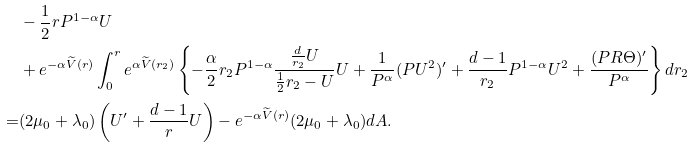<formula> <loc_0><loc_0><loc_500><loc_500>& - \frac { 1 } { 2 } r P ^ { 1 - \alpha } U \\ & + e ^ { - \alpha \widetilde { V } ( r ) } \int _ { 0 } ^ { r } e ^ { \alpha \widetilde { V } ( r _ { 2 } ) } \left \{ - \frac { \alpha } { 2 } r _ { 2 } P ^ { 1 - \alpha } \frac { \frac { d } { r _ { 2 } } U } { \frac { 1 } { 2 } r _ { 2 } - U } U + \frac { 1 } { P ^ { \alpha } } ( P U ^ { 2 } ) ^ { \prime } + \frac { d - 1 } { r _ { 2 } } P ^ { 1 - \alpha } U ^ { 2 } + \frac { ( P R \Theta ) ^ { \prime } } { P ^ { \alpha } } \right \} d r _ { 2 } \\ = & ( 2 \mu _ { 0 } + \lambda _ { 0 } ) \left ( U ^ { \prime } + \frac { d - 1 } { r } U \right ) - e ^ { - \alpha \widetilde { V } ( r ) } ( 2 \mu _ { 0 } + \lambda _ { 0 } ) d A .</formula> 